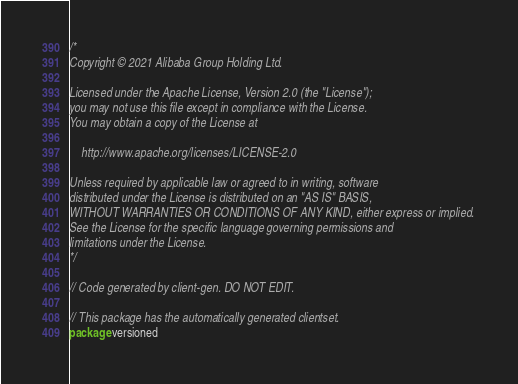Convert code to text. <code><loc_0><loc_0><loc_500><loc_500><_Go_>/*
Copyright © 2021 Alibaba Group Holding Ltd.

Licensed under the Apache License, Version 2.0 (the "License");
you may not use this file except in compliance with the License.
You may obtain a copy of the License at

    http://www.apache.org/licenses/LICENSE-2.0

Unless required by applicable law or agreed to in writing, software
distributed under the License is distributed on an "AS IS" BASIS,
WITHOUT WARRANTIES OR CONDITIONS OF ANY KIND, either express or implied.
See the License for the specific language governing permissions and
limitations under the License.
*/

// Code generated by client-gen. DO NOT EDIT.

// This package has the automatically generated clientset.
package versioned
</code> 